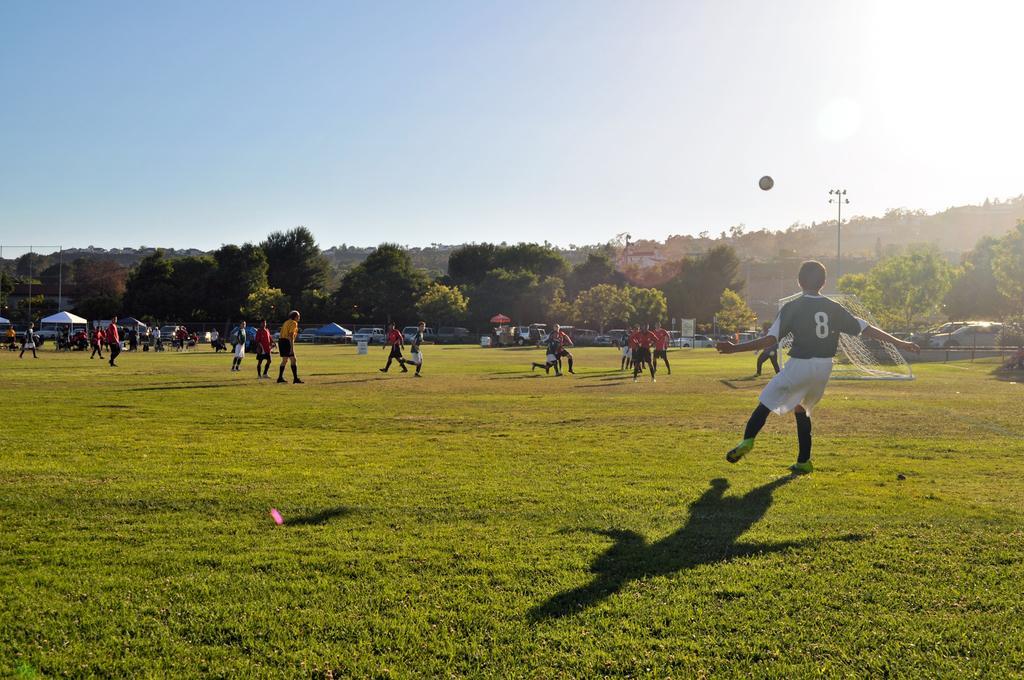In one or two sentences, can you explain what this image depicts? In this picture I can see there are few players in the playground and there are wearing jerseys and there is a net on to right and there are few tents and vehicles parked in the backdrop and there are trees, poles and there is a mountain in the backdrop and the sky is clear and sunny. 